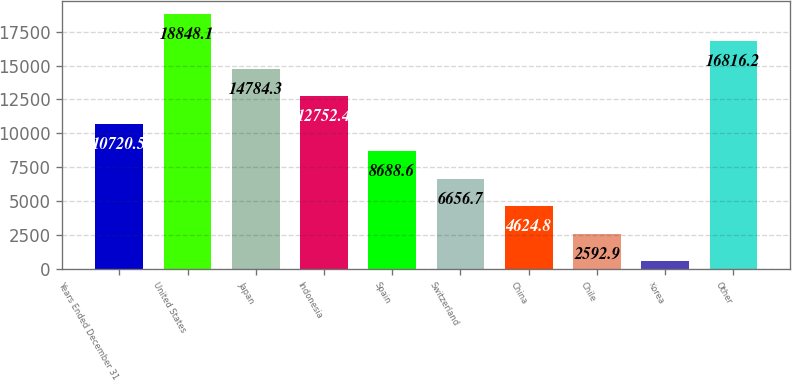Convert chart to OTSL. <chart><loc_0><loc_0><loc_500><loc_500><bar_chart><fcel>Years Ended December 31<fcel>United States<fcel>Japan<fcel>Indonesia<fcel>Spain<fcel>Switzerland<fcel>China<fcel>Chile<fcel>Korea<fcel>Other<nl><fcel>10720.5<fcel>18848.1<fcel>14784.3<fcel>12752.4<fcel>8688.6<fcel>6656.7<fcel>4624.8<fcel>2592.9<fcel>561<fcel>16816.2<nl></chart> 